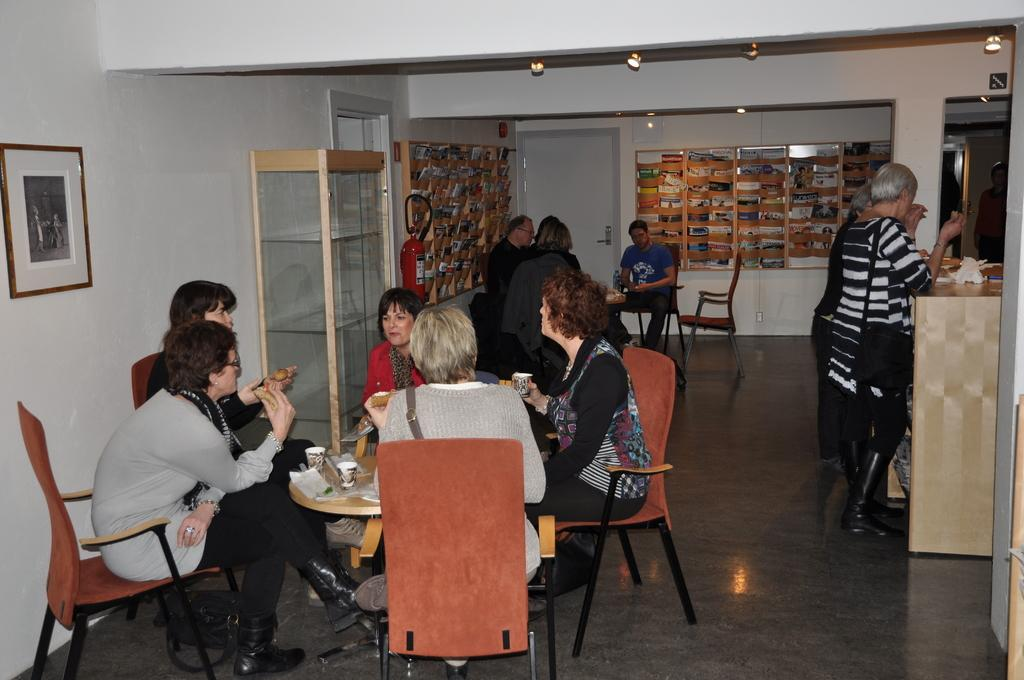What are the people in the image doing? There are people seated on chairs and people standing in the image. What can be seen on the wall in the image? There is a bookshelf on the wall in the image. What type of mint is growing on the bookshelf in the image? There is no mint growing on the bookshelf in the image. Can you describe the angle at which the people are standing in the image? The angle at which the people are standing cannot be determined from the image. 